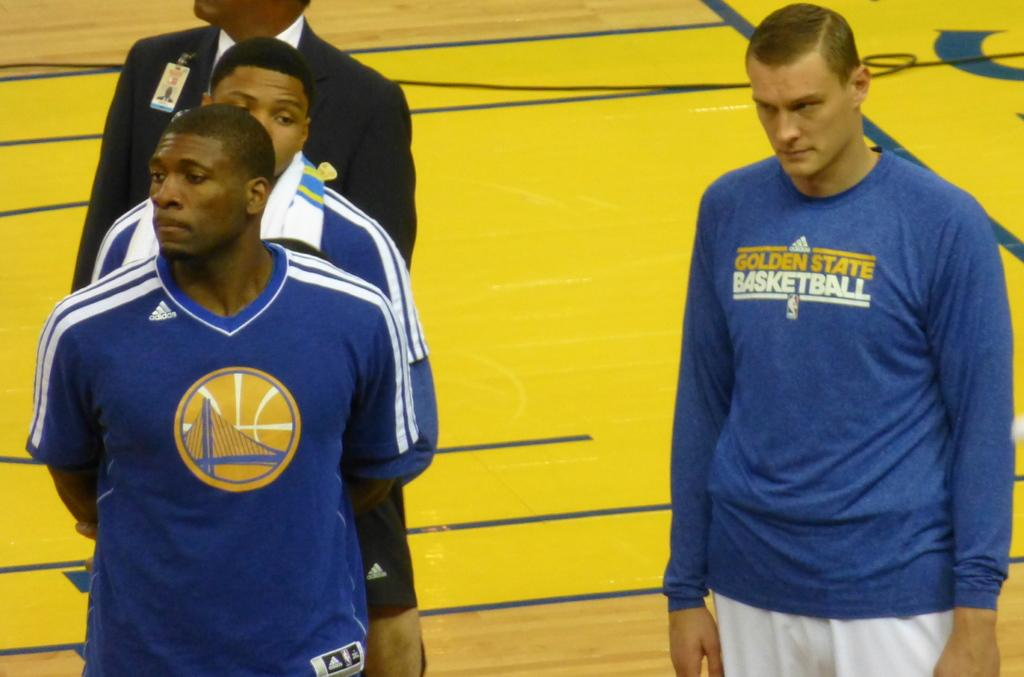<image>
Relay a brief, clear account of the picture shown. A young man wearing a Golden State Basketball sweatshirt stands off to the side of some other players. 